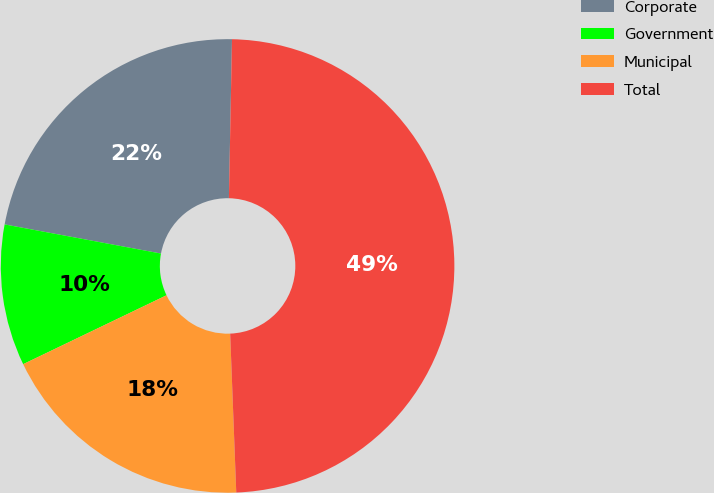Convert chart to OTSL. <chart><loc_0><loc_0><loc_500><loc_500><pie_chart><fcel>Corporate<fcel>Government<fcel>Municipal<fcel>Total<nl><fcel>22.38%<fcel>10.06%<fcel>18.48%<fcel>49.08%<nl></chart> 